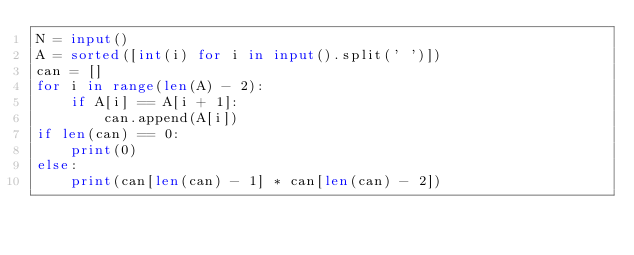Convert code to text. <code><loc_0><loc_0><loc_500><loc_500><_Python_>N = input()
A = sorted([int(i) for i in input().split(' ')])
can = []
for i in range(len(A) - 2):
    if A[i] == A[i + 1]:
        can.append(A[i])
if len(can) == 0:
    print(0)
else:
    print(can[len(can) - 1] * can[len(can) - 2])
</code> 